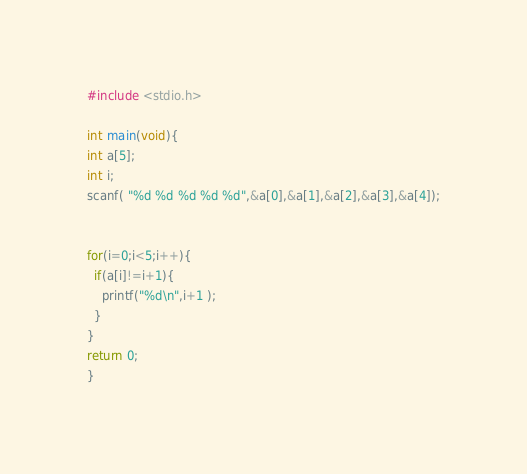Convert code to text. <code><loc_0><loc_0><loc_500><loc_500><_C_>#include <stdio.h>

int main(void){
int a[5];
int i;
scanf( "%d %d %d %d %d",&a[0],&a[1],&a[2],&a[3],&a[4]);


for(i=0;i<5;i++){
  if(a[i]!=i+1){
    printf("%d\n",i+1 );
  }
}
return 0;
}
</code> 